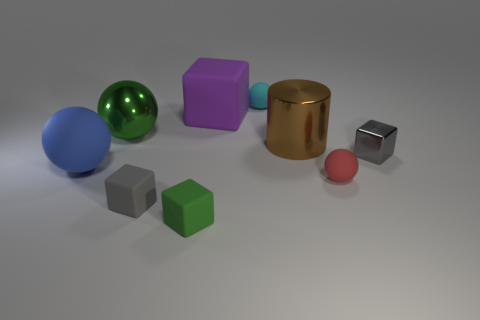Add 1 tiny yellow objects. How many objects exist? 10 Subtract all big blocks. How many blocks are left? 3 Subtract all cyan balls. How many gray blocks are left? 2 Subtract all purple cubes. How many cubes are left? 3 Add 7 big brown metal cylinders. How many big brown metal cylinders are left? 8 Add 9 big purple objects. How many big purple objects exist? 10 Subtract 1 gray cubes. How many objects are left? 8 Subtract all blocks. How many objects are left? 5 Subtract all blue spheres. Subtract all green cylinders. How many spheres are left? 3 Subtract all small metal things. Subtract all small gray metallic cubes. How many objects are left? 7 